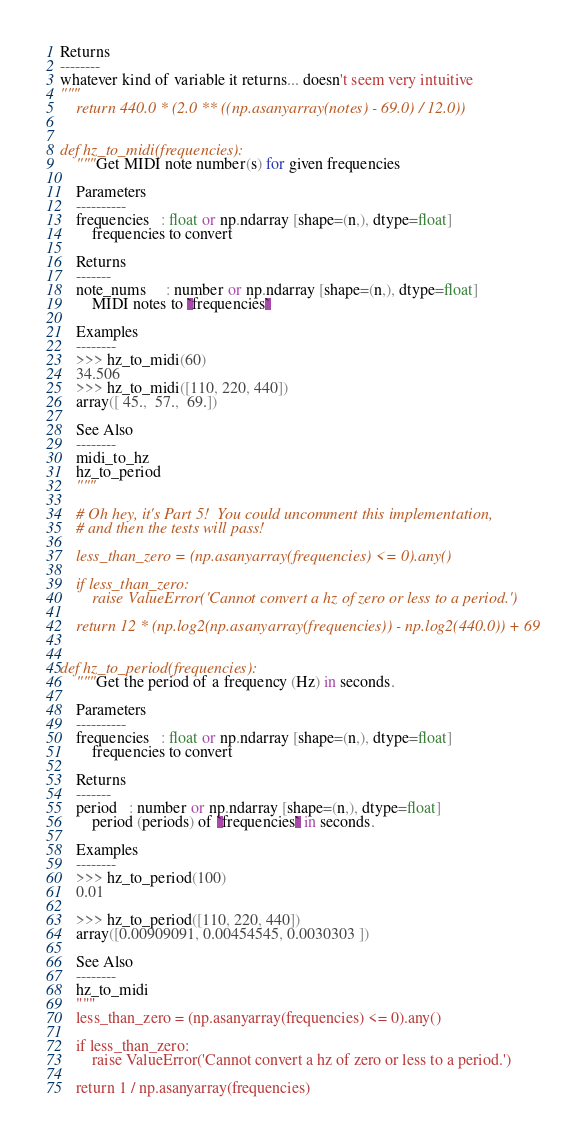<code> <loc_0><loc_0><loc_500><loc_500><_Python_>
Returns
--------
whatever kind of variable it returns... doesn't seem very intuitive    
"""
    return 440.0 * (2.0 ** ((np.asanyarray(notes) - 69.0) / 12.0))


def hz_to_midi(frequencies):
    """Get MIDI note number(s) for given frequencies

    Parameters
    ----------
    frequencies   : float or np.ndarray [shape=(n,), dtype=float]
        frequencies to convert

    Returns
    -------
    note_nums     : number or np.ndarray [shape=(n,), dtype=float]
        MIDI notes to `frequencies`

    Examples
    --------
    >>> hz_to_midi(60)
    34.506
    >>> hz_to_midi([110, 220, 440])
    array([ 45.,  57.,  69.])

    See Also
    --------
    midi_to_hz
    hz_to_period
    """

    # Oh hey, it's Part 5!  You could uncomment this implementation,
    # and then the tests will pass!

    less_than_zero = (np.asanyarray(frequencies) <= 0).any()

    if less_than_zero:
        raise ValueError('Cannot convert a hz of zero or less to a period.')

    return 12 * (np.log2(np.asanyarray(frequencies)) - np.log2(440.0)) + 69


def hz_to_period(frequencies):
    """Get the period of a frequency (Hz) in seconds.

    Parameters
    ----------
    frequencies   : float or np.ndarray [shape=(n,), dtype=float]
        frequencies to convert

    Returns
    -------
    period   : number or np.ndarray [shape=(n,), dtype=float]
        period (periods) of `frequencies` in seconds.

    Examples
    --------
    >>> hz_to_period(100)
    0.01

    >>> hz_to_period([110, 220, 440])
    array([0.00909091, 0.00454545, 0.0030303 ])

    See Also
    --------
    hz_to_midi
    """
    less_than_zero = (np.asanyarray(frequencies) <= 0).any()

    if less_than_zero:
        raise ValueError('Cannot convert a hz of zero or less to a period.')

    return 1 / np.asanyarray(frequencies)
</code> 